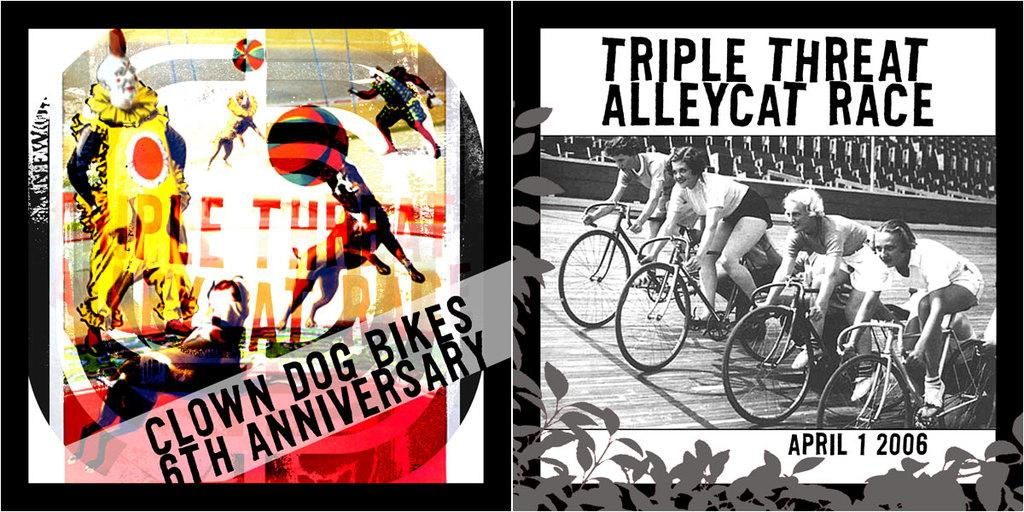<image>
Share a concise interpretation of the image provided. A poster for Clown Dog Bikes 6th Anniversary next to a posterfor another bike race. 